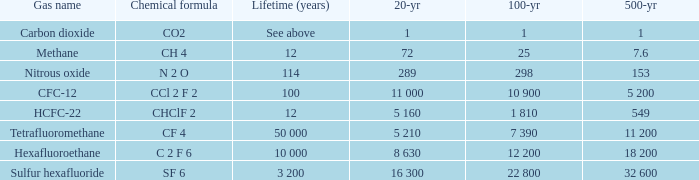What is the hundred-year span when five-century span is 153? 298.0. 